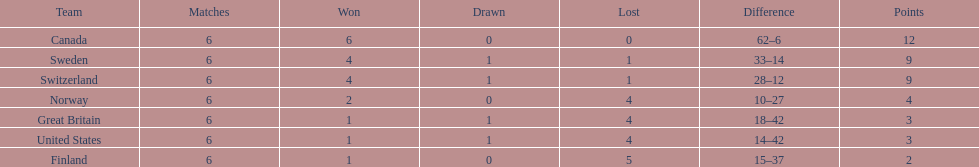Which country's team came in last place during the 1951 world ice hockey championships? Finland. 